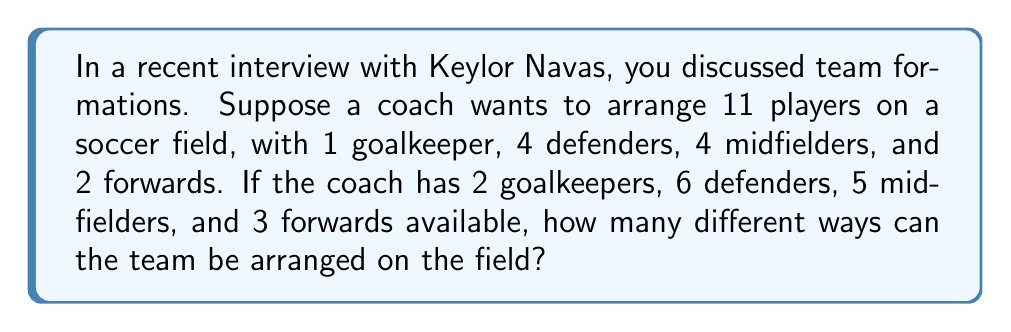Teach me how to tackle this problem. Let's break this down step-by-step:

1) First, we need to choose players for each position:
   - Choose 1 goalkeeper out of 2: $\binom{2}{1}$
   - Choose 4 defenders out of 6: $\binom{6}{4}$
   - Choose 4 midfielders out of 5: $\binom{5}{4}$
   - Choose 2 forwards out of 3: $\binom{3}{2}$

2) The number of ways to choose players for each position is:
   $$\binom{2}{1} \cdot \binom{6}{4} \cdot \binom{5}{4} \cdot \binom{3}{2}$$

3) Let's calculate each combination:
   - $\binom{2}{1} = 2$
   - $\binom{6}{4} = \frac{6!}{4!(6-4)!} = \frac{6 \cdot 5}{2 \cdot 1} = 15$
   - $\binom{5}{4} = \frac{5!}{4!(5-4)!} = 5$
   - $\binom{3}{2} = \frac{3!}{2!(3-2)!} = 3$

4) Multiply these numbers:
   $$2 \cdot 15 \cdot 5 \cdot 3 = 450$$

5) Now, for each selection of players, we need to consider the number of ways to arrange them on the field:
   - 4! ways to arrange the defenders
   - 4! ways to arrange the midfielders
   - 2! ways to arrange the forwards

6) The total number of arrangements is:
   $$450 \cdot 4! \cdot 4! \cdot 2!$$

7) Calculate the final result:
   $$450 \cdot 24 \cdot 24 \cdot 2 = 518,400$$
Answer: 518,400 